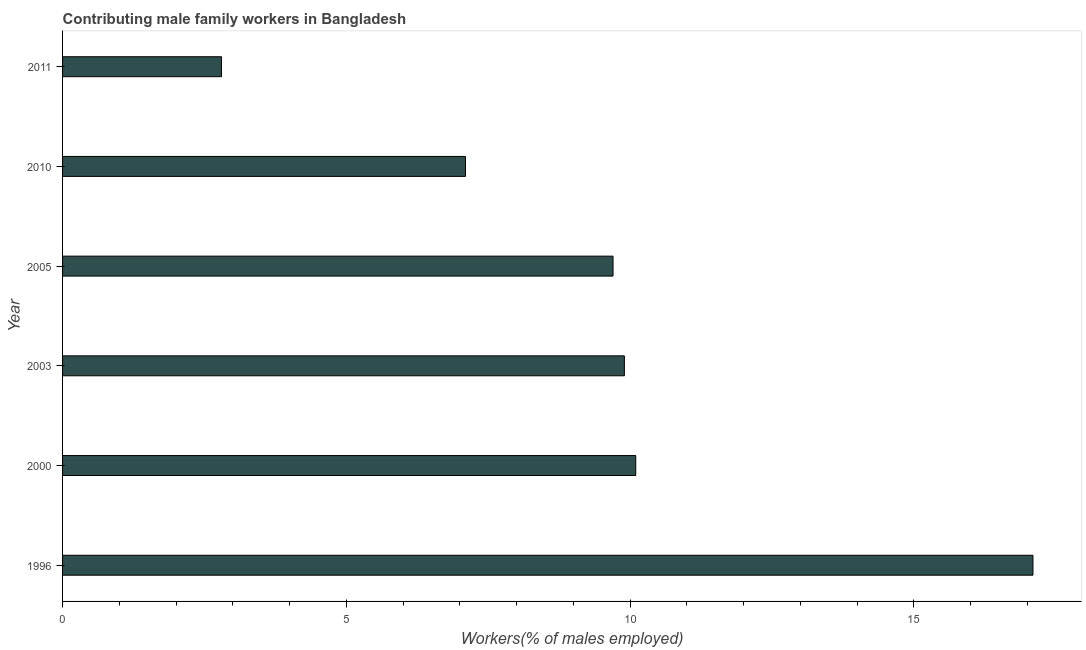Does the graph contain any zero values?
Provide a short and direct response. No. Does the graph contain grids?
Provide a succinct answer. No. What is the title of the graph?
Ensure brevity in your answer.  Contributing male family workers in Bangladesh. What is the label or title of the X-axis?
Keep it short and to the point. Workers(% of males employed). What is the label or title of the Y-axis?
Your answer should be compact. Year. What is the contributing male family workers in 2011?
Provide a short and direct response. 2.8. Across all years, what is the maximum contributing male family workers?
Provide a succinct answer. 17.1. Across all years, what is the minimum contributing male family workers?
Your response must be concise. 2.8. In which year was the contributing male family workers maximum?
Your response must be concise. 1996. What is the sum of the contributing male family workers?
Your answer should be compact. 56.7. What is the average contributing male family workers per year?
Your response must be concise. 9.45. What is the median contributing male family workers?
Offer a very short reply. 9.8. Do a majority of the years between 2000 and 1996 (inclusive) have contributing male family workers greater than 7 %?
Keep it short and to the point. No. Is the difference between the contributing male family workers in 2000 and 2003 greater than the difference between any two years?
Your answer should be very brief. No. What is the difference between the highest and the second highest contributing male family workers?
Provide a succinct answer. 7. What is the difference between the highest and the lowest contributing male family workers?
Keep it short and to the point. 14.3. How many bars are there?
Ensure brevity in your answer.  6. What is the difference between two consecutive major ticks on the X-axis?
Offer a terse response. 5. What is the Workers(% of males employed) of 1996?
Keep it short and to the point. 17.1. What is the Workers(% of males employed) of 2000?
Offer a very short reply. 10.1. What is the Workers(% of males employed) of 2003?
Ensure brevity in your answer.  9.9. What is the Workers(% of males employed) of 2005?
Keep it short and to the point. 9.7. What is the Workers(% of males employed) of 2010?
Offer a terse response. 7.1. What is the Workers(% of males employed) of 2011?
Your answer should be very brief. 2.8. What is the difference between the Workers(% of males employed) in 1996 and 2003?
Offer a very short reply. 7.2. What is the difference between the Workers(% of males employed) in 1996 and 2010?
Provide a succinct answer. 10. What is the difference between the Workers(% of males employed) in 1996 and 2011?
Offer a very short reply. 14.3. What is the difference between the Workers(% of males employed) in 2000 and 2005?
Offer a very short reply. 0.4. What is the difference between the Workers(% of males employed) in 2003 and 2005?
Your answer should be very brief. 0.2. What is the difference between the Workers(% of males employed) in 2003 and 2010?
Keep it short and to the point. 2.8. What is the difference between the Workers(% of males employed) in 2003 and 2011?
Offer a very short reply. 7.1. What is the difference between the Workers(% of males employed) in 2005 and 2010?
Provide a succinct answer. 2.6. What is the difference between the Workers(% of males employed) in 2010 and 2011?
Ensure brevity in your answer.  4.3. What is the ratio of the Workers(% of males employed) in 1996 to that in 2000?
Offer a very short reply. 1.69. What is the ratio of the Workers(% of males employed) in 1996 to that in 2003?
Provide a short and direct response. 1.73. What is the ratio of the Workers(% of males employed) in 1996 to that in 2005?
Your answer should be very brief. 1.76. What is the ratio of the Workers(% of males employed) in 1996 to that in 2010?
Provide a succinct answer. 2.41. What is the ratio of the Workers(% of males employed) in 1996 to that in 2011?
Give a very brief answer. 6.11. What is the ratio of the Workers(% of males employed) in 2000 to that in 2005?
Keep it short and to the point. 1.04. What is the ratio of the Workers(% of males employed) in 2000 to that in 2010?
Your answer should be very brief. 1.42. What is the ratio of the Workers(% of males employed) in 2000 to that in 2011?
Offer a terse response. 3.61. What is the ratio of the Workers(% of males employed) in 2003 to that in 2005?
Make the answer very short. 1.02. What is the ratio of the Workers(% of males employed) in 2003 to that in 2010?
Offer a terse response. 1.39. What is the ratio of the Workers(% of males employed) in 2003 to that in 2011?
Ensure brevity in your answer.  3.54. What is the ratio of the Workers(% of males employed) in 2005 to that in 2010?
Offer a very short reply. 1.37. What is the ratio of the Workers(% of males employed) in 2005 to that in 2011?
Offer a terse response. 3.46. What is the ratio of the Workers(% of males employed) in 2010 to that in 2011?
Provide a short and direct response. 2.54. 